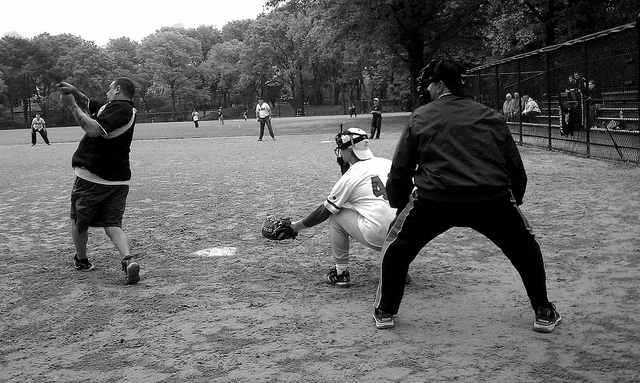<image>Is this a Little League team? I am not sure if this is a Little League team. Is this a Little League team? I am not sure if this is a Little League team. It is possible that it is not. 